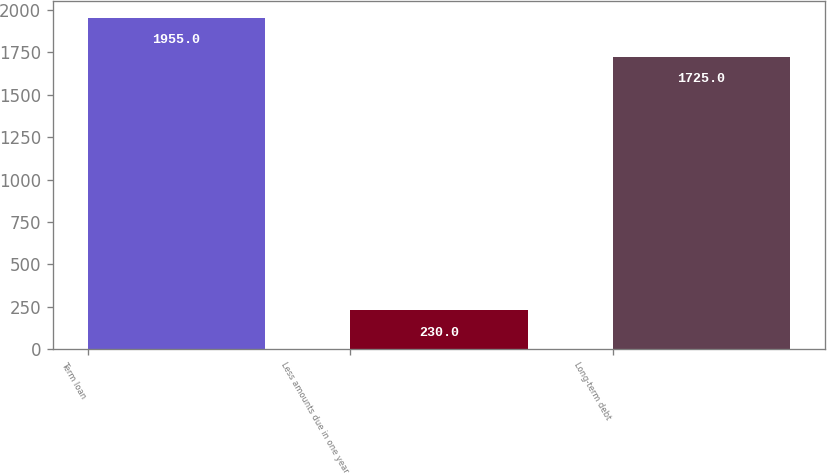Convert chart. <chart><loc_0><loc_0><loc_500><loc_500><bar_chart><fcel>Term loan<fcel>Less amounts due in one year<fcel>Long-term debt<nl><fcel>1955<fcel>230<fcel>1725<nl></chart> 